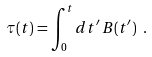<formula> <loc_0><loc_0><loc_500><loc_500>\tau ( t ) = \int _ { 0 } ^ { t } d t ^ { \prime } \, B ( t ^ { \prime } ) \ .</formula> 